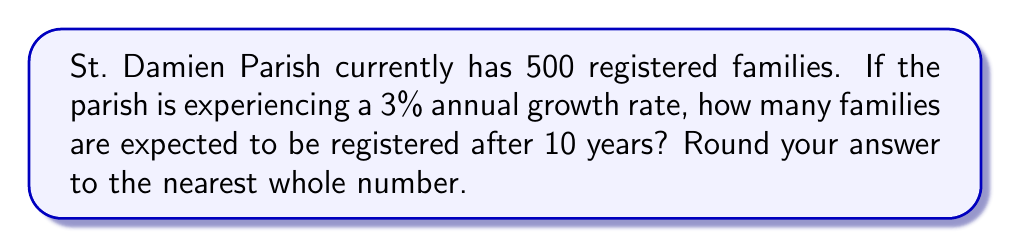What is the answer to this math problem? To solve this problem, we'll use the exponential growth formula:

$$A = P(1 + r)^t$$

Where:
$A$ = final amount
$P$ = initial amount (principal)
$r$ = growth rate (as a decimal)
$t$ = time period

Given:
$P = 500$ families
$r = 0.03$ (3% expressed as a decimal)
$t = 10$ years

Let's substitute these values into the formula:

$$A = 500(1 + 0.03)^{10}$$

Now, let's calculate step-by-step:

1) First, calculate $(1 + 0.03)$:
   $1 + 0.03 = 1.03$

2) Now, we have:
   $$A = 500(1.03)^{10}$$

3) Calculate $(1.03)^{10}$:
   $(1.03)^{10} \approx 1.3439$

4) Multiply by 500:
   $500 \times 1.3439 = 671.95$

5) Round to the nearest whole number:
   $671.95 \approx 672$

Therefore, after 10 years, St. Damien Parish is expected to have approximately 672 registered families.
Answer: 672 families 